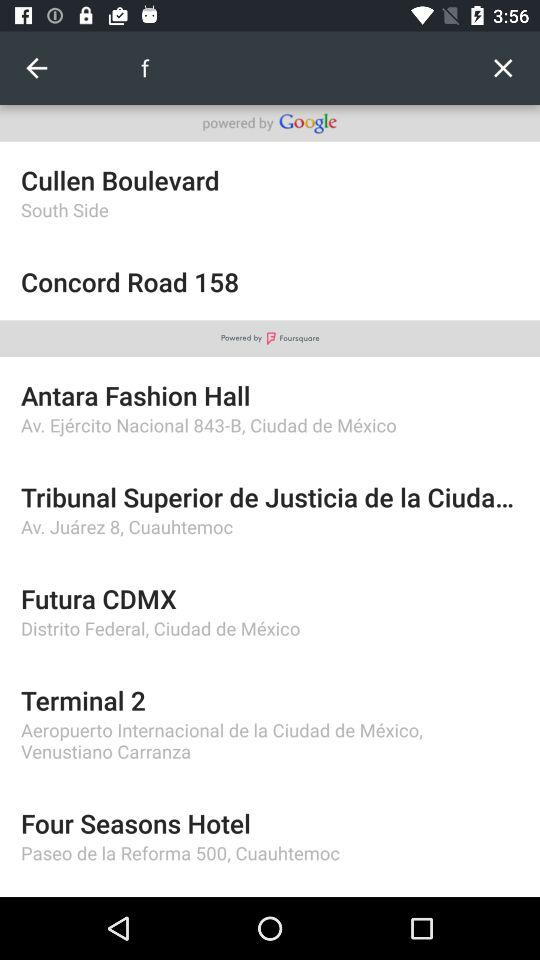What is the address of "Terminal 2"? The address is Aeropuerto Internacional de la Ciudad de Mexico, Venustiano Carranza. 